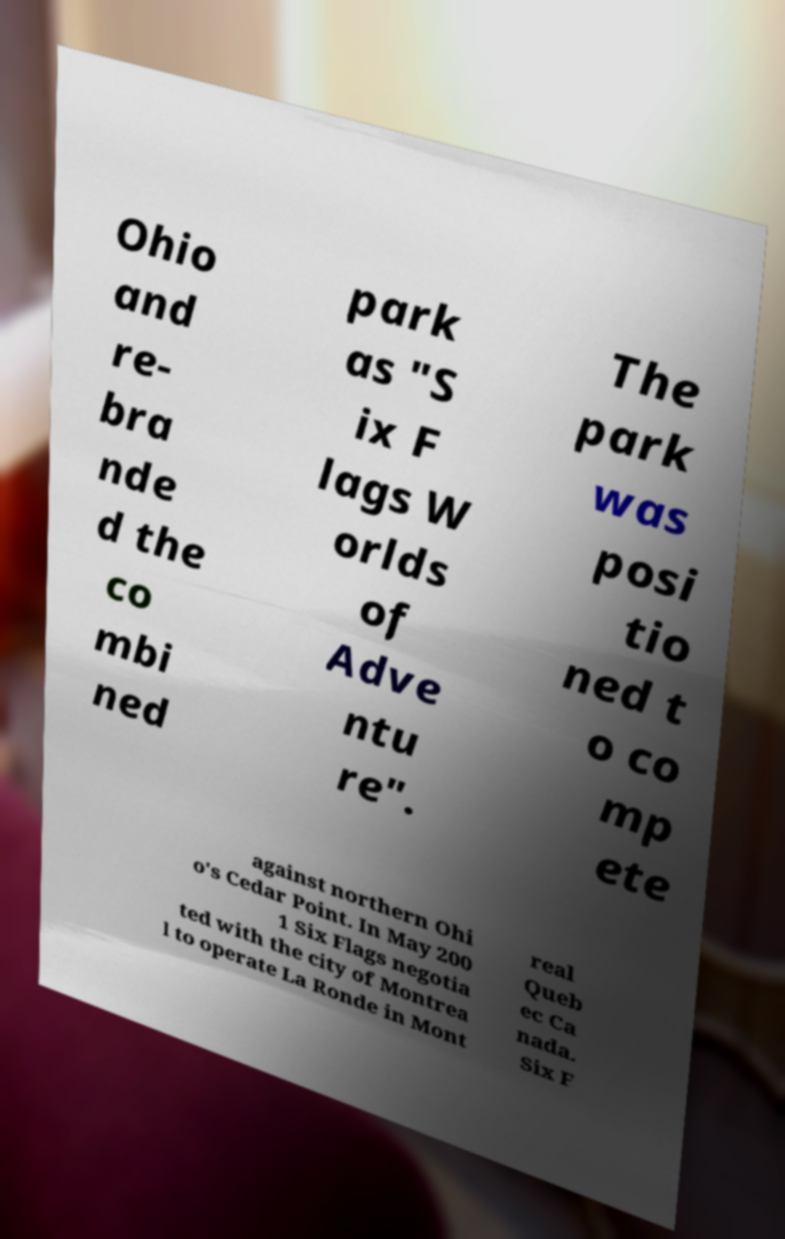Please identify and transcribe the text found in this image. Ohio and re- bra nde d the co mbi ned park as "S ix F lags W orlds of Adve ntu re". The park was posi tio ned t o co mp ete against northern Ohi o's Cedar Point. In May 200 1 Six Flags negotia ted with the city of Montrea l to operate La Ronde in Mont real Queb ec Ca nada. Six F 